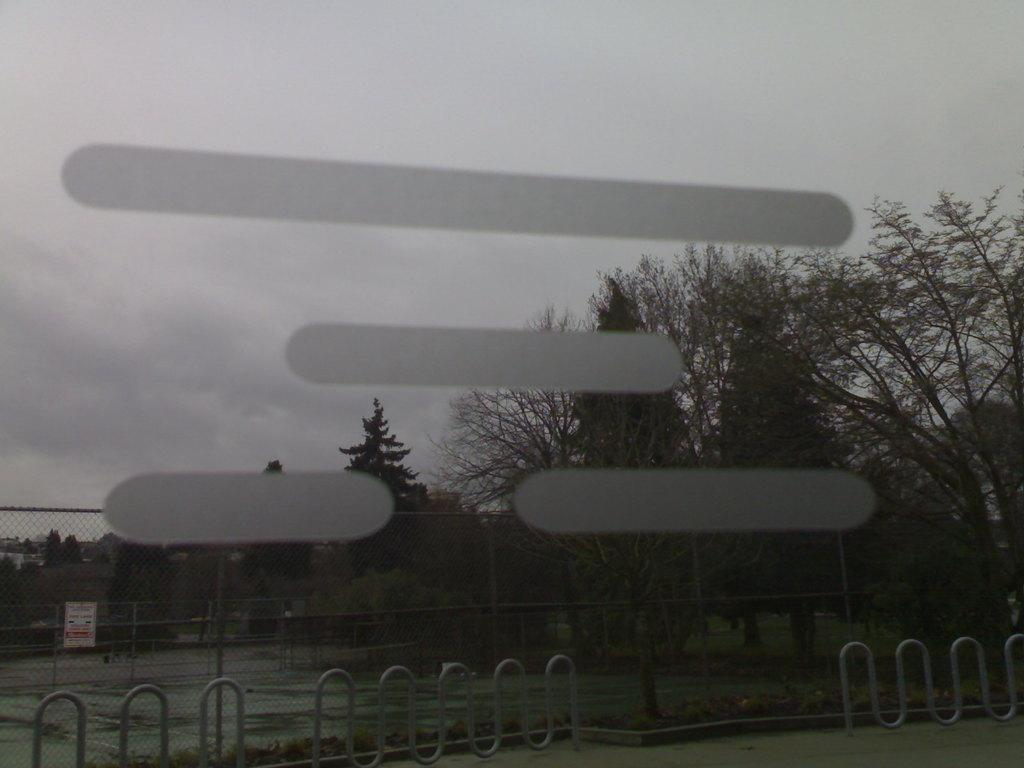What type of vegetation can be seen in the image? There are trees in the image. What is covering the ground in the image? The ground is covered with a fence. What is the condition of the sky in the image? The sky is cloudy in the image. What type of wax is visible on the trees in the image? There is no wax visible on the trees in the image; only trees are present. What question is being asked by the trees in the image? There are no questions being asked by the trees in the image, as trees do not have the ability to ask questions. 